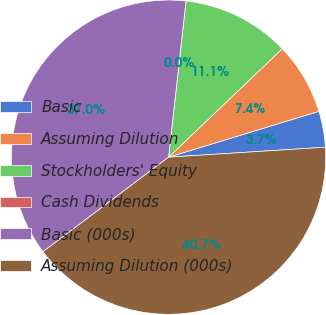<chart> <loc_0><loc_0><loc_500><loc_500><pie_chart><fcel>Basic<fcel>Assuming Dilution<fcel>Stockholders' Equity<fcel>Cash Dividends<fcel>Basic (000s)<fcel>Assuming Dilution (000s)<nl><fcel>3.7%<fcel>7.41%<fcel>11.11%<fcel>0.0%<fcel>37.04%<fcel>40.74%<nl></chart> 